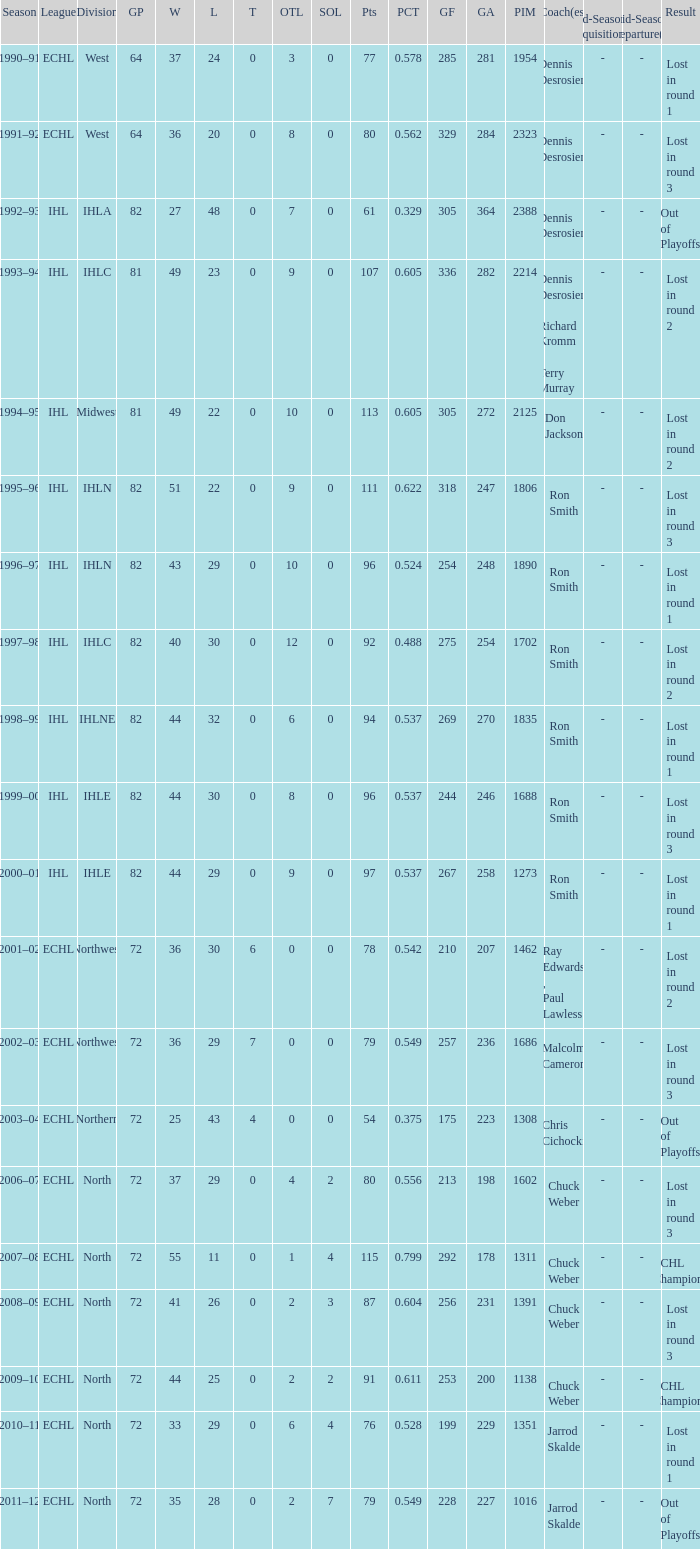What was the highest SOL where the team lost in round 3? 3.0. 